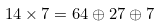<formula> <loc_0><loc_0><loc_500><loc_500>1 4 \times 7 = 6 4 \oplus 2 7 \oplus 7</formula> 